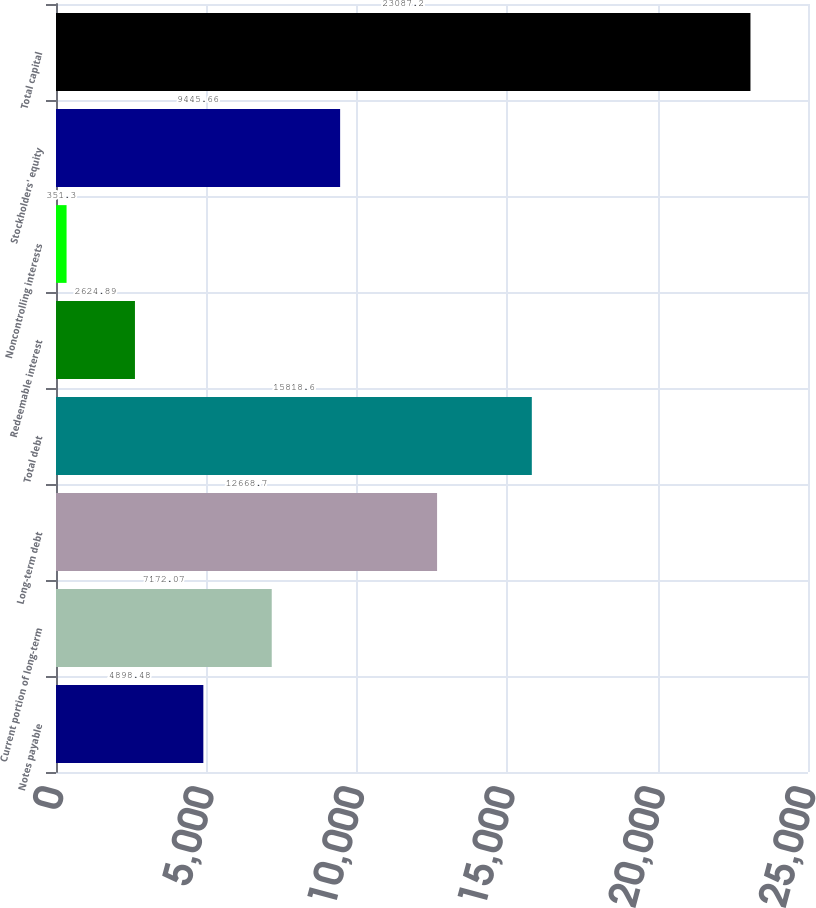Convert chart. <chart><loc_0><loc_0><loc_500><loc_500><bar_chart><fcel>Notes payable<fcel>Current portion of long-term<fcel>Long-term debt<fcel>Total debt<fcel>Redeemable interest<fcel>Noncontrolling interests<fcel>Stockholders' equity<fcel>Total capital<nl><fcel>4898.48<fcel>7172.07<fcel>12668.7<fcel>15818.6<fcel>2624.89<fcel>351.3<fcel>9445.66<fcel>23087.2<nl></chart> 